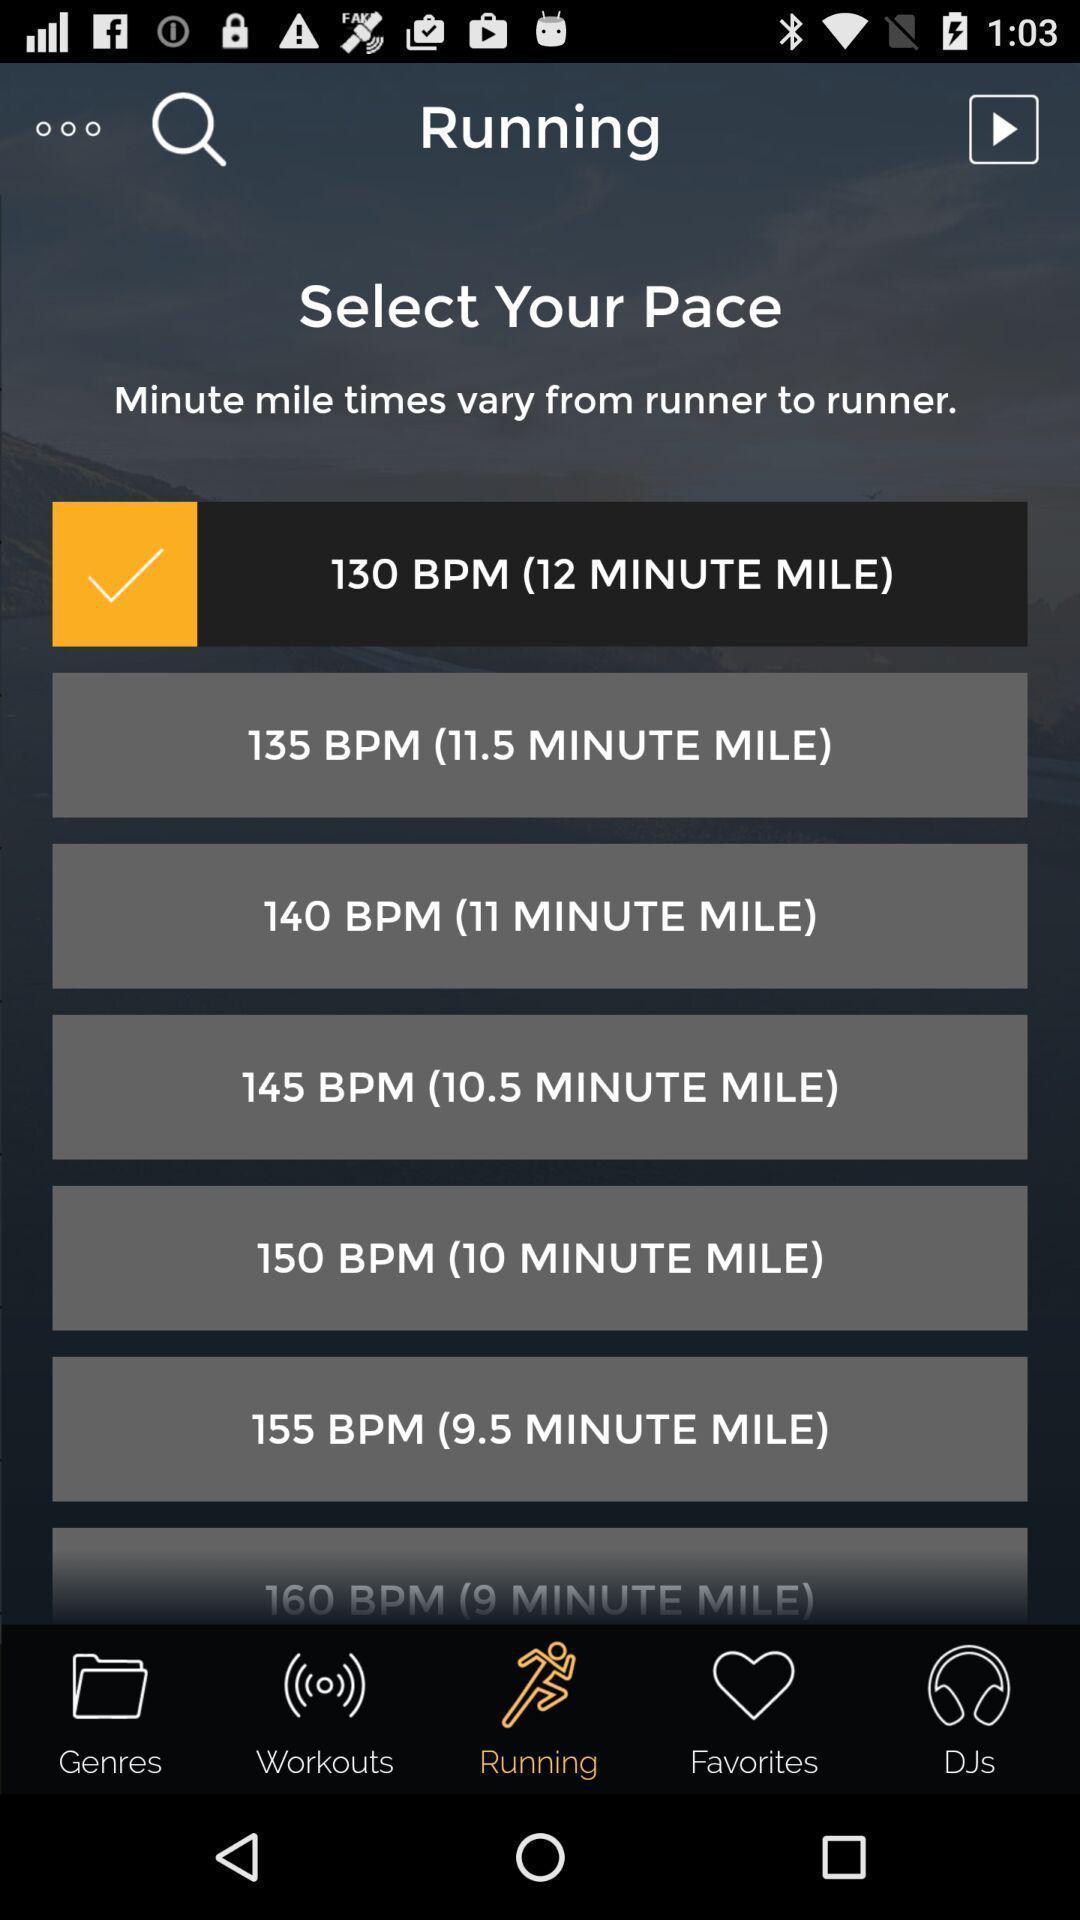Please provide a description for this image. Screen page displaying multiple options in fitness application. 